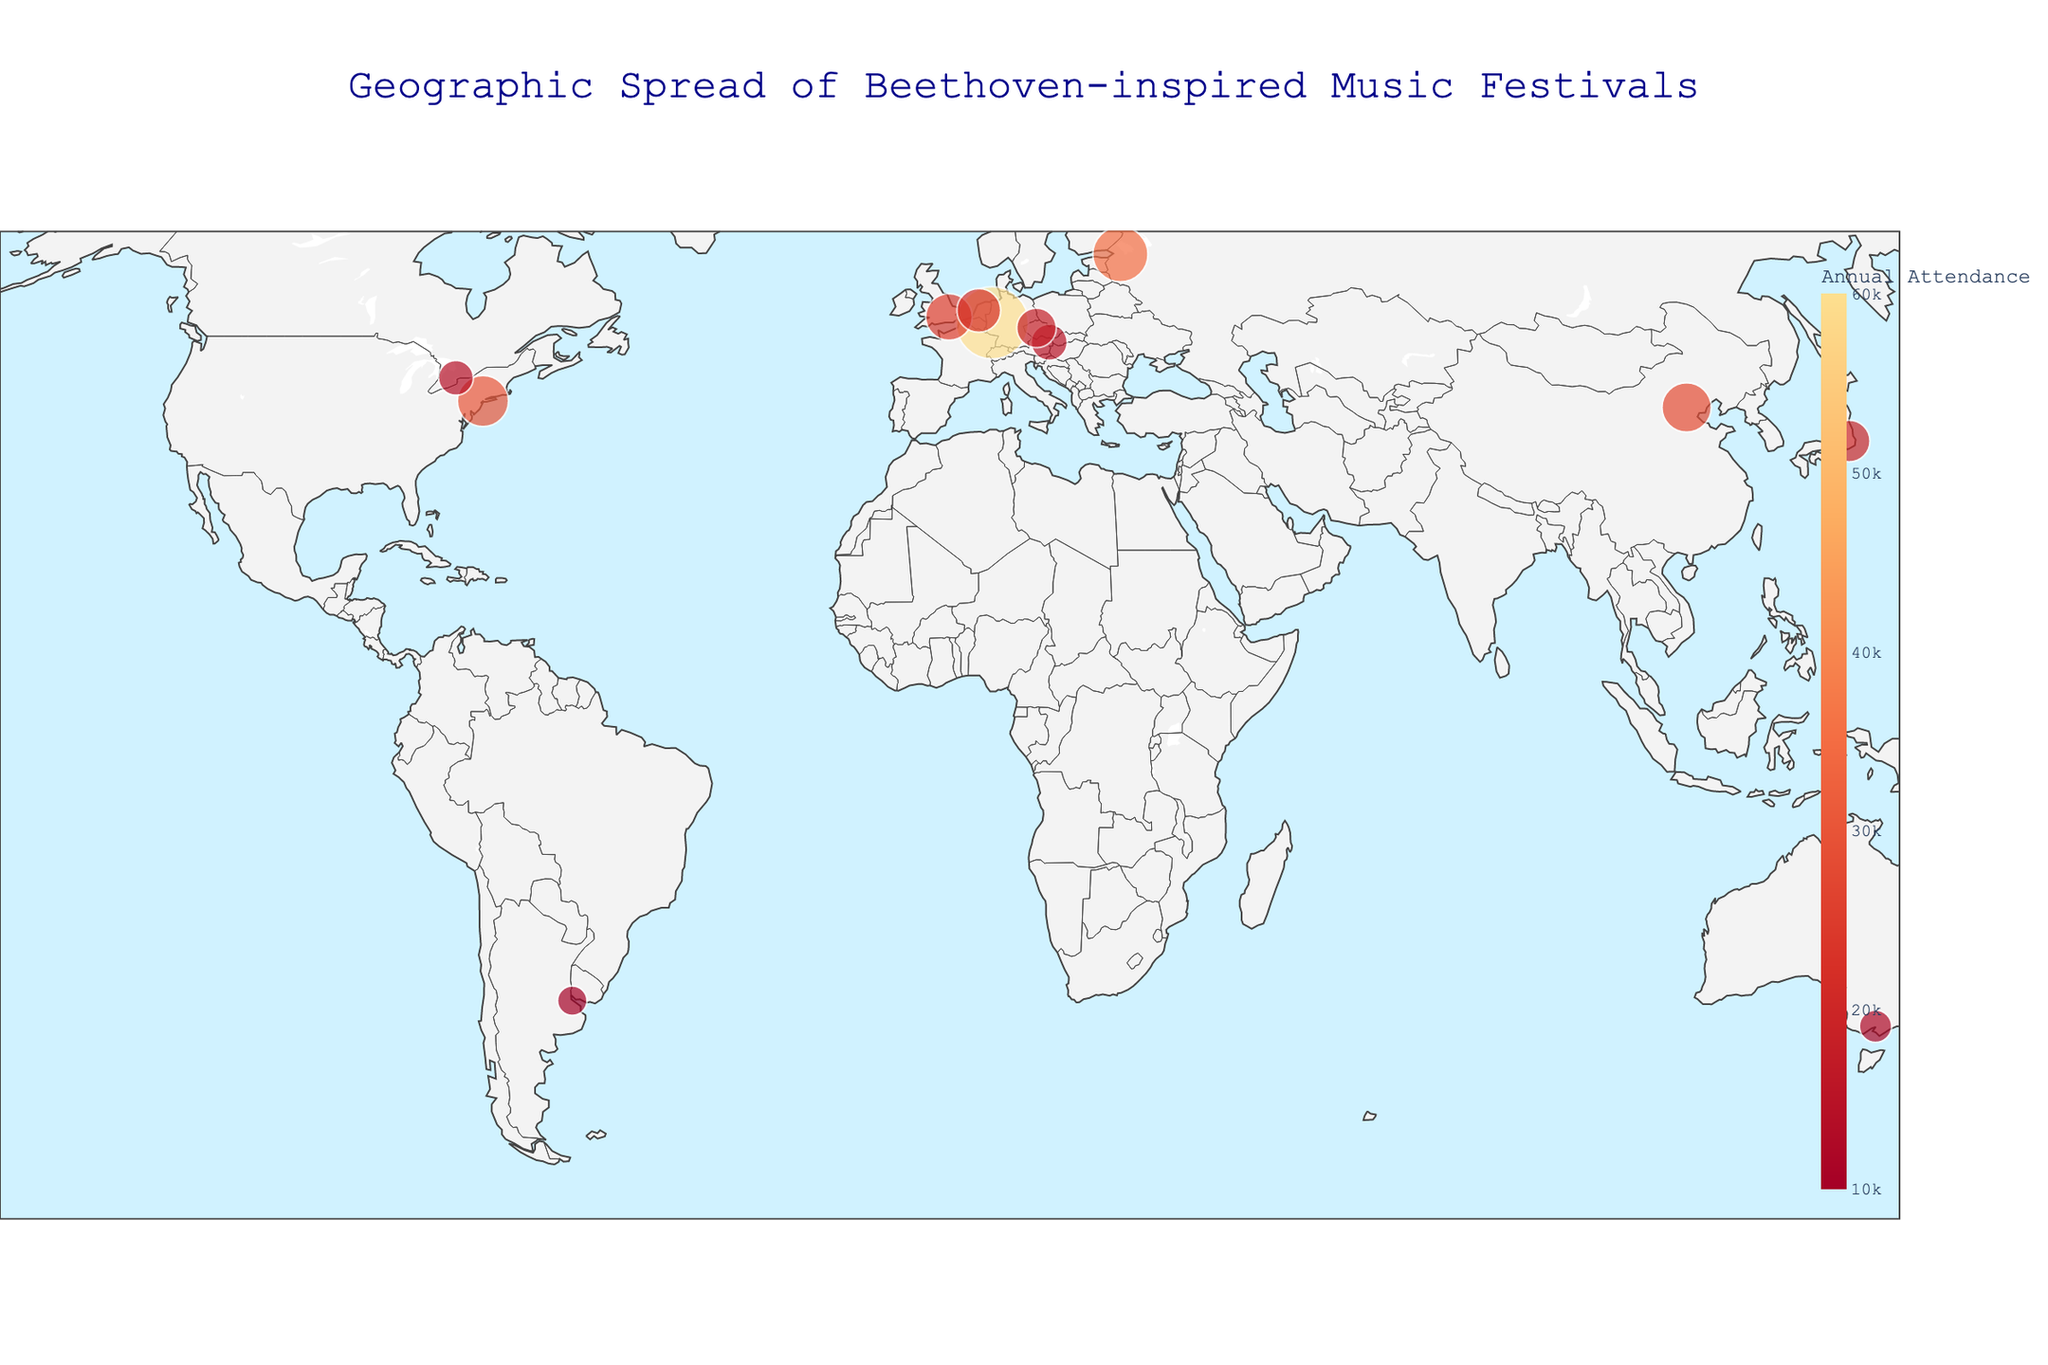What is the title of the figure? The title of the figure is usually located at the top, often highlighted in a larger or bolder font compared to other texts. In this figure, the title reads "Geographic Spread of Beethoven-inspired Music Festivals."
Answer: Geographic Spread of Beethoven-inspired Music Festivals How many festivals are represented in the figure? Each festival is represented by a point on the map. You can count the points to determine the number of festivals.
Answer: 12 Which festival has the highest annual attendance? Look for the largest circle on the map, as the size of the circles represents the annual attendance. The largest circle is in Bonn, Germany, indicating the Beethovenfest Bonn.
Answer: Beethovenfest Bonn What is the latitude and longitude of the festival in Beijing? Locate Beijing on the map and check the hover data that displays when you mouse over the point. The hover text will show the latitude and longitude.
Answer: 39.9042, 116.4074 Which city hosts the "Beethoven Down Under" festival? Check the hover data for the festival names and locate "Beethoven Down Under." The corresponding city can be read from the hover text.
Answer: Melbourne Which continents have the highest concentration of Beethoven-inspired music festivals? By examining the geographic distribution of points on the map, you can see that Europe has the highest concentration of festivals compared to other continents.
Answer: Europe What is the combined annual attendance of all festivals in Europe? First, identify all festivals located in Europe: Vienna, Bonn, London, Prague, Amsterdam. Then sum their annual attendance figures: 15000 + 60000 + 25000 + 18000 + 22000.
Answer: 140000 Which festival has higher attendance: "Beethoven Celebration NYC" or "Tokyo Beethoven Marathon"? Compare the sizes of the circles representing these festivals on the map. The circle for NYC is larger than the one for Tokyo, indicating higher attendance.
Answer: Beethoven Celebration NYC What is the annual attendance difference between the "White Nights Beethoven Festival" in St. Petersburg and "Beethoven en Buenos Aires"? The annual attendance for these festivals can be found in the hover data. Subtract the attendance of Buenos Aires (10000) from St. Petersburg (35000) to get the difference.
Answer: 25000 Which festival in South America is represented in the figure? Check for the point on the map located in South America and refer to the hover data to find the festival name.
Answer: Beethoven en Buenos Aires 